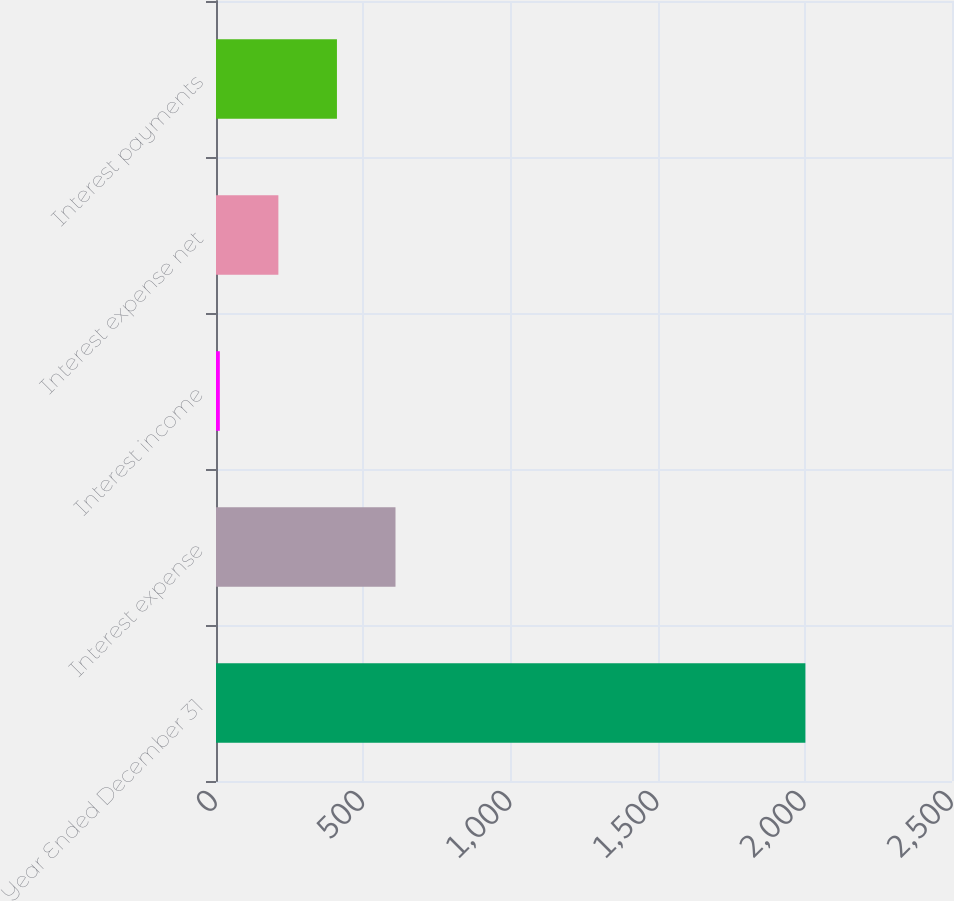Convert chart to OTSL. <chart><loc_0><loc_0><loc_500><loc_500><bar_chart><fcel>Year Ended December 31<fcel>Interest expense<fcel>Interest income<fcel>Interest expense net<fcel>Interest payments<nl><fcel>2002<fcel>609.7<fcel>13<fcel>211.9<fcel>410.8<nl></chart> 